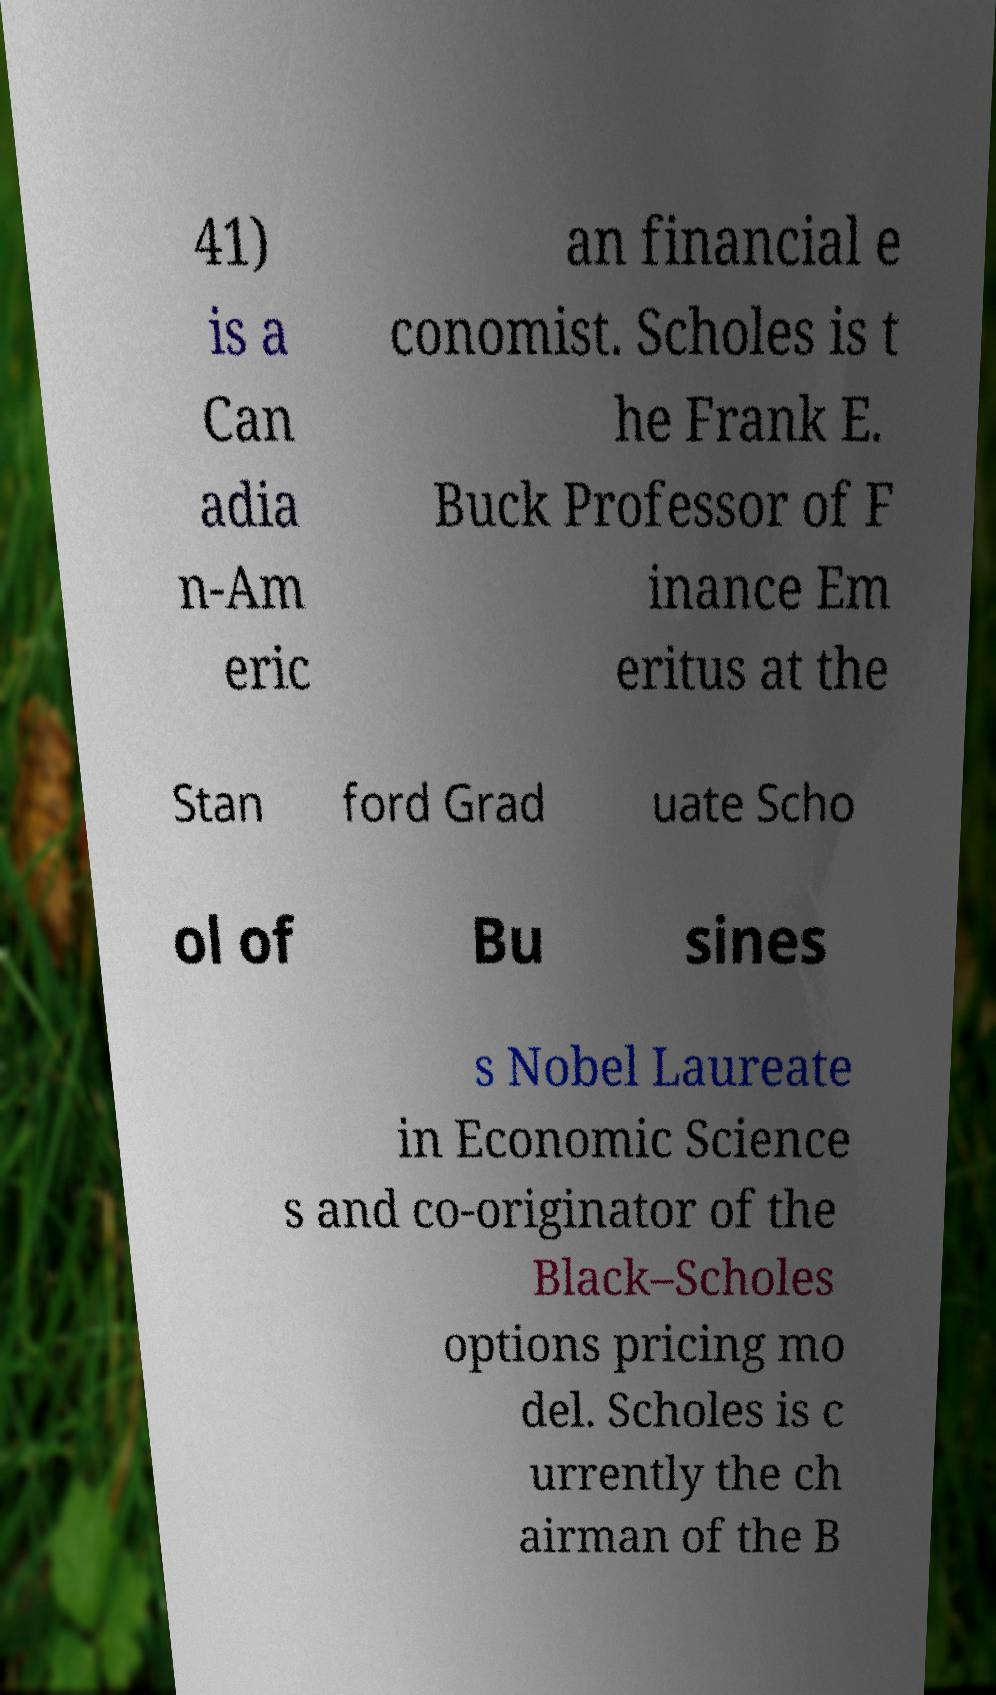There's text embedded in this image that I need extracted. Can you transcribe it verbatim? 41) is a Can adia n-Am eric an financial e conomist. Scholes is t he Frank E. Buck Professor of F inance Em eritus at the Stan ford Grad uate Scho ol of Bu sines s Nobel Laureate in Economic Science s and co-originator of the Black–Scholes options pricing mo del. Scholes is c urrently the ch airman of the B 